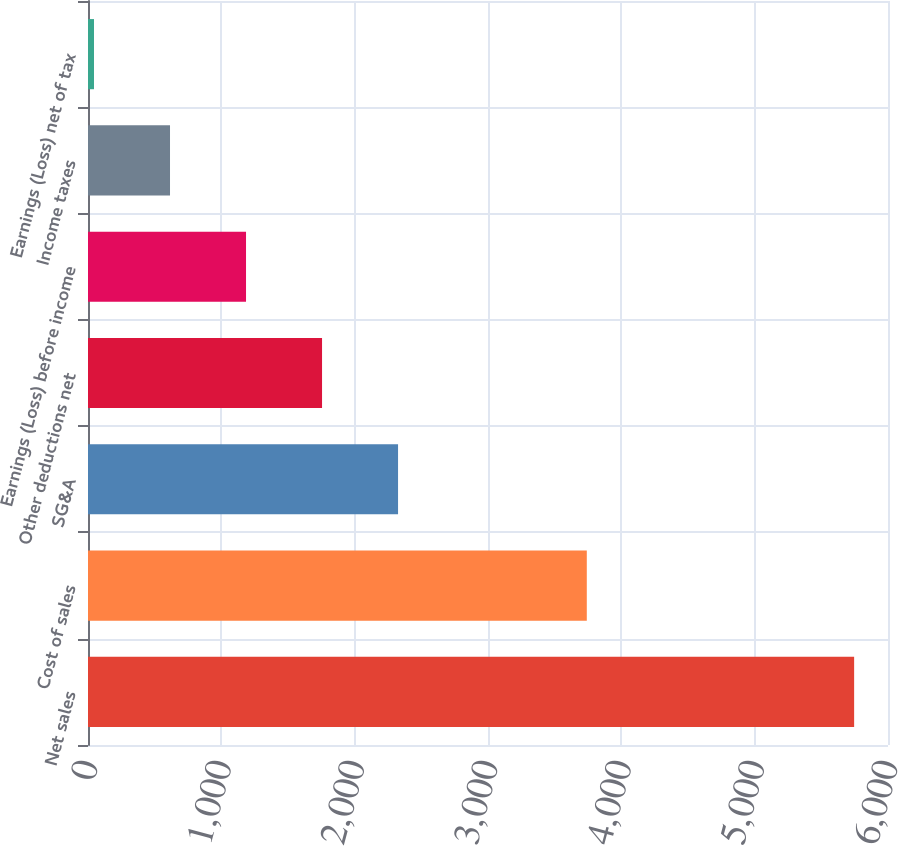<chart> <loc_0><loc_0><loc_500><loc_500><bar_chart><fcel>Net sales<fcel>Cost of sales<fcel>SG&A<fcel>Other deductions net<fcel>Earnings (Loss) before income<fcel>Income taxes<fcel>Earnings (Loss) net of tax<nl><fcel>5746<fcel>3741<fcel>2325.4<fcel>1755.3<fcel>1185.2<fcel>615.1<fcel>45<nl></chart> 